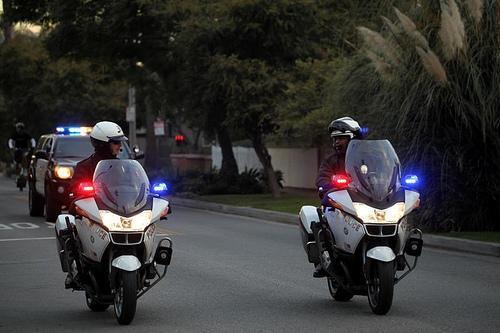How many motorcycles are there?
Give a very brief answer. 2. 